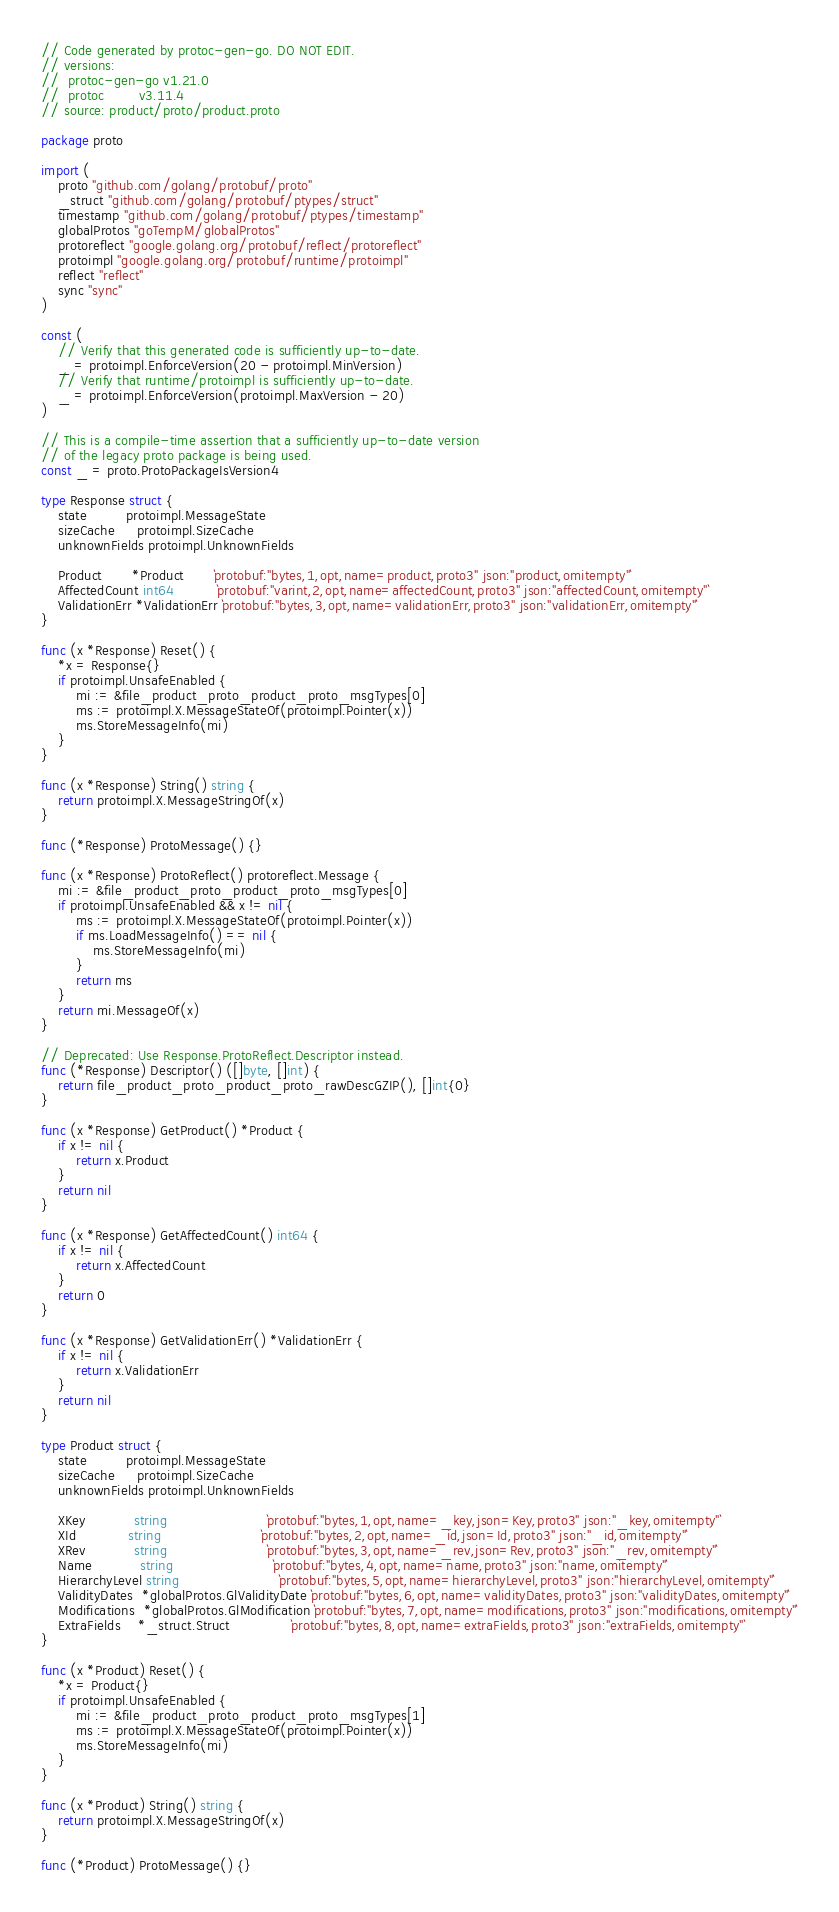<code> <loc_0><loc_0><loc_500><loc_500><_Go_>// Code generated by protoc-gen-go. DO NOT EDIT.
// versions:
// 	protoc-gen-go v1.21.0
// 	protoc        v3.11.4
// source: product/proto/product.proto

package proto

import (
	proto "github.com/golang/protobuf/proto"
	_struct "github.com/golang/protobuf/ptypes/struct"
	timestamp "github.com/golang/protobuf/ptypes/timestamp"
	globalProtos "goTempM/globalProtos"
	protoreflect "google.golang.org/protobuf/reflect/protoreflect"
	protoimpl "google.golang.org/protobuf/runtime/protoimpl"
	reflect "reflect"
	sync "sync"
)

const (
	// Verify that this generated code is sufficiently up-to-date.
	_ = protoimpl.EnforceVersion(20 - protoimpl.MinVersion)
	// Verify that runtime/protoimpl is sufficiently up-to-date.
	_ = protoimpl.EnforceVersion(protoimpl.MaxVersion - 20)
)

// This is a compile-time assertion that a sufficiently up-to-date version
// of the legacy proto package is being used.
const _ = proto.ProtoPackageIsVersion4

type Response struct {
	state         protoimpl.MessageState
	sizeCache     protoimpl.SizeCache
	unknownFields protoimpl.UnknownFields

	Product       *Product       `protobuf:"bytes,1,opt,name=product,proto3" json:"product,omitempty"`
	AffectedCount int64          `protobuf:"varint,2,opt,name=affectedCount,proto3" json:"affectedCount,omitempty"`
	ValidationErr *ValidationErr `protobuf:"bytes,3,opt,name=validationErr,proto3" json:"validationErr,omitempty"`
}

func (x *Response) Reset() {
	*x = Response{}
	if protoimpl.UnsafeEnabled {
		mi := &file_product_proto_product_proto_msgTypes[0]
		ms := protoimpl.X.MessageStateOf(protoimpl.Pointer(x))
		ms.StoreMessageInfo(mi)
	}
}

func (x *Response) String() string {
	return protoimpl.X.MessageStringOf(x)
}

func (*Response) ProtoMessage() {}

func (x *Response) ProtoReflect() protoreflect.Message {
	mi := &file_product_proto_product_proto_msgTypes[0]
	if protoimpl.UnsafeEnabled && x != nil {
		ms := protoimpl.X.MessageStateOf(protoimpl.Pointer(x))
		if ms.LoadMessageInfo() == nil {
			ms.StoreMessageInfo(mi)
		}
		return ms
	}
	return mi.MessageOf(x)
}

// Deprecated: Use Response.ProtoReflect.Descriptor instead.
func (*Response) Descriptor() ([]byte, []int) {
	return file_product_proto_product_proto_rawDescGZIP(), []int{0}
}

func (x *Response) GetProduct() *Product {
	if x != nil {
		return x.Product
	}
	return nil
}

func (x *Response) GetAffectedCount() int64 {
	if x != nil {
		return x.AffectedCount
	}
	return 0
}

func (x *Response) GetValidationErr() *ValidationErr {
	if x != nil {
		return x.ValidationErr
	}
	return nil
}

type Product struct {
	state         protoimpl.MessageState
	sizeCache     protoimpl.SizeCache
	unknownFields protoimpl.UnknownFields

	XKey           string                       `protobuf:"bytes,1,opt,name=_key,json=Key,proto3" json:"_key,omitempty"`
	XId            string                       `protobuf:"bytes,2,opt,name=_id,json=Id,proto3" json:"_id,omitempty"`
	XRev           string                       `protobuf:"bytes,3,opt,name=_rev,json=Rev,proto3" json:"_rev,omitempty"`
	Name           string                       `protobuf:"bytes,4,opt,name=name,proto3" json:"name,omitempty"`
	HierarchyLevel string                       `protobuf:"bytes,5,opt,name=hierarchyLevel,proto3" json:"hierarchyLevel,omitempty"`
	ValidityDates  *globalProtos.GlValidityDate `protobuf:"bytes,6,opt,name=validityDates,proto3" json:"validityDates,omitempty"`
	Modifications  *globalProtos.GlModification `protobuf:"bytes,7,opt,name=modifications,proto3" json:"modifications,omitempty"`
	ExtraFields    *_struct.Struct              `protobuf:"bytes,8,opt,name=extraFields,proto3" json:"extraFields,omitempty"`
}

func (x *Product) Reset() {
	*x = Product{}
	if protoimpl.UnsafeEnabled {
		mi := &file_product_proto_product_proto_msgTypes[1]
		ms := protoimpl.X.MessageStateOf(protoimpl.Pointer(x))
		ms.StoreMessageInfo(mi)
	}
}

func (x *Product) String() string {
	return protoimpl.X.MessageStringOf(x)
}

func (*Product) ProtoMessage() {}
</code> 